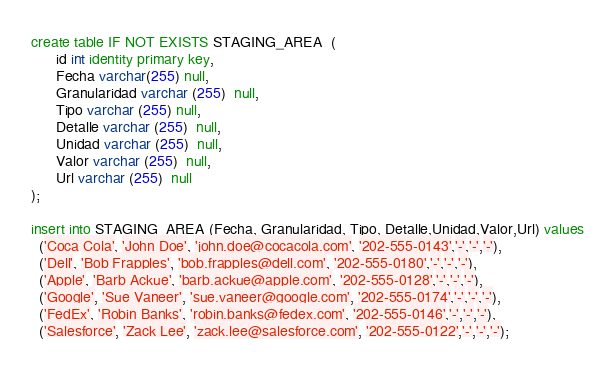<code> <loc_0><loc_0><loc_500><loc_500><_SQL_>

create table IF NOT EXISTS STAGING_AREA  (
      id int identity primary key,
      Fecha varchar(255) null,
      Granularidad varchar (255)  null,
      Tipo varchar (255) null,
      Detalle varchar (255)  null,
      Unidad varchar (255)  null,
      Valor varchar (255)  null,
      Url varchar (255)  null
);

insert into STAGING_AREA (Fecha, Granularidad, Tipo, Detalle,Unidad,Valor,Url) values
  ('Coca Cola', 'John Doe', 'john.doe@cocacola.com', '202-555-0143','-','-','-'),
  ('Dell', 'Bob Frapples', 'bob.frapples@dell.com', '202-555-0180','-','-','-'),
  ('Apple', 'Barb Ackue', 'barb.ackue@apple.com', '202-555-0128','-','-','-'),
  ('Google', 'Sue Vaneer', 'sue.vaneer@google.com', '202-555-0174','-','-','-'),
  ('FedEx', 'Robin Banks', 'robin.banks@fedex.com', '202-555-0146','-','-','-'),
  ('Salesforce', 'Zack Lee', 'zack.lee@salesforce.com', '202-555-0122','-','-','-');</code> 